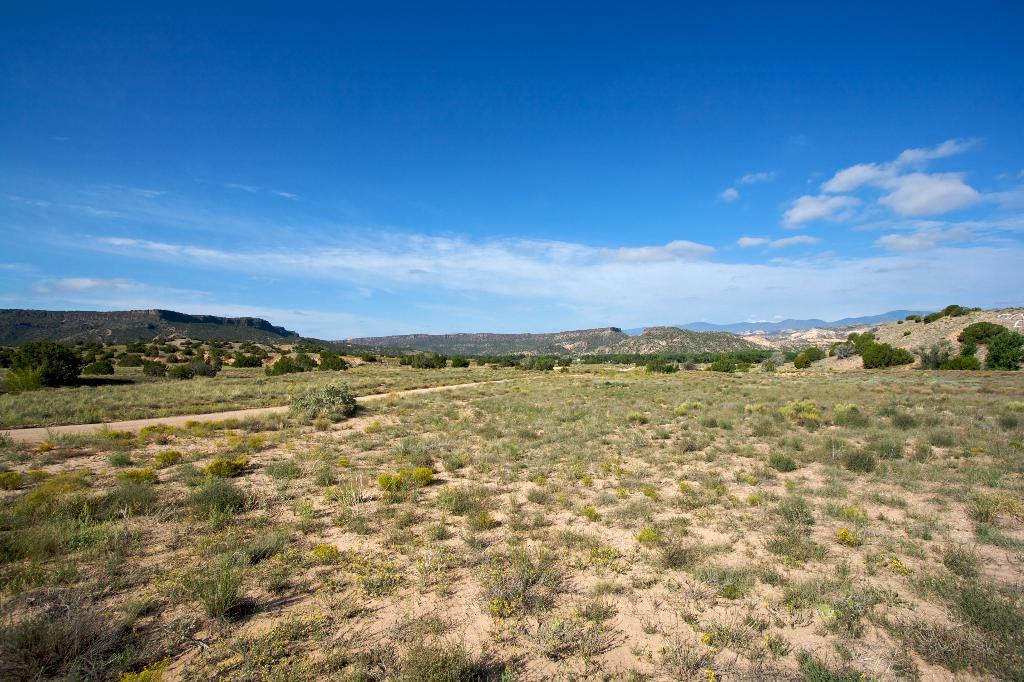What type of vegetation is present on the ground in the image? There is grass and plants on the ground in the image. What can be seen in the distance in the image? There are mountains in the background of the image. What is visible in the sky in the background of the image? There are clouds in the sky in the background of the image. Where is the sofa located in the image? There is no sofa present in the image. What type of prose can be read in the image? There is no prose present in the image. 